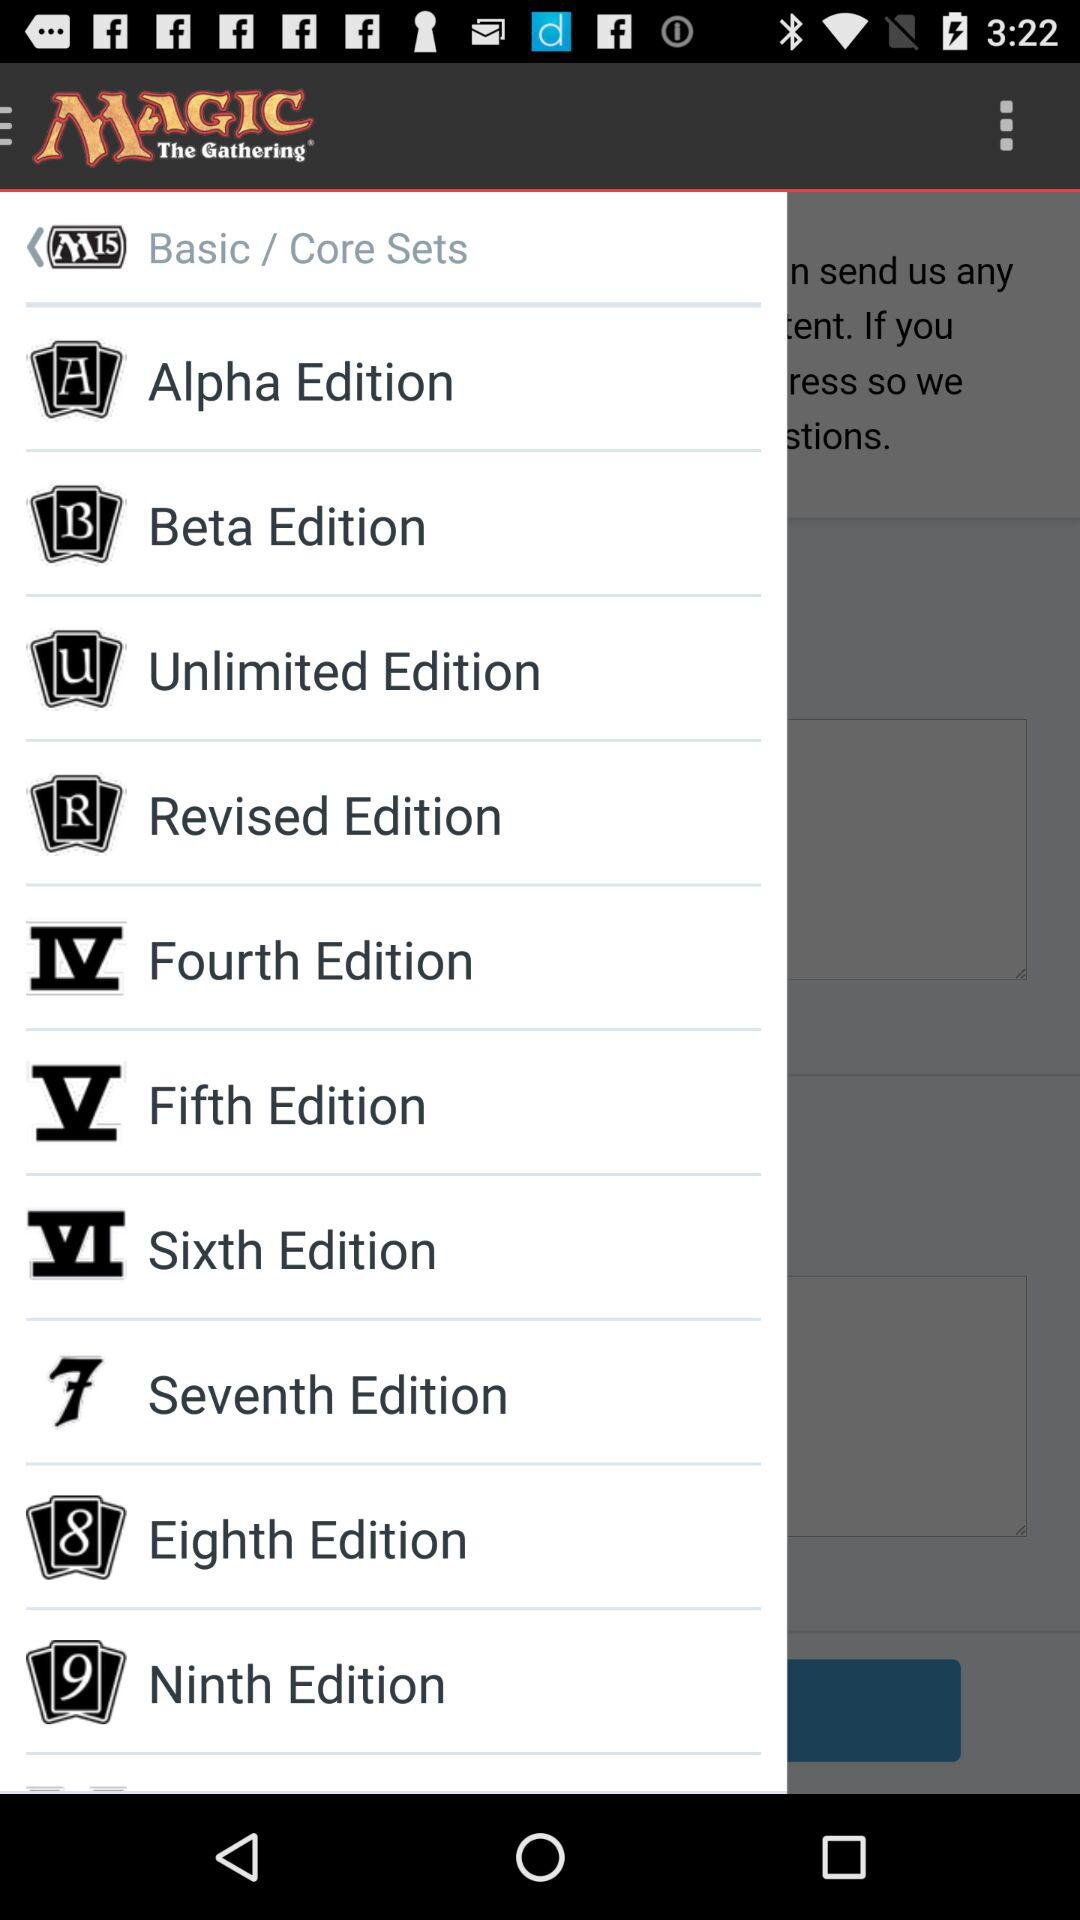What is the name of the application? The name of the application is "Magic The Gathering". 